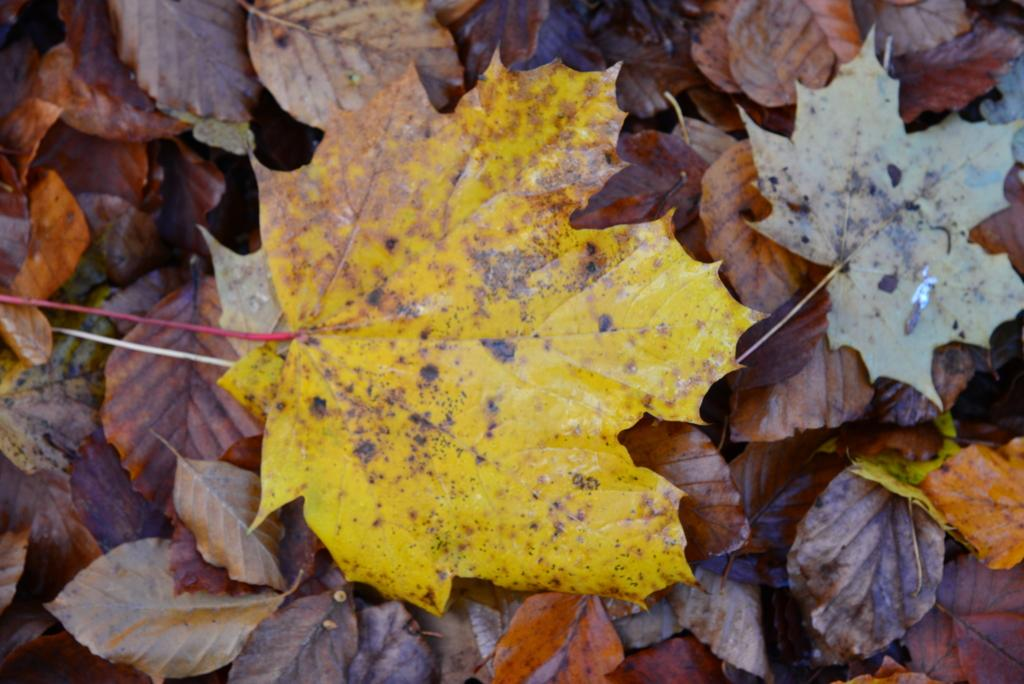What type of vegetation can be seen in the image? There are leaves in the image. How many geese are resting on the sheet in the image? There are no geese or sheets present in the image; it only features leaves. 